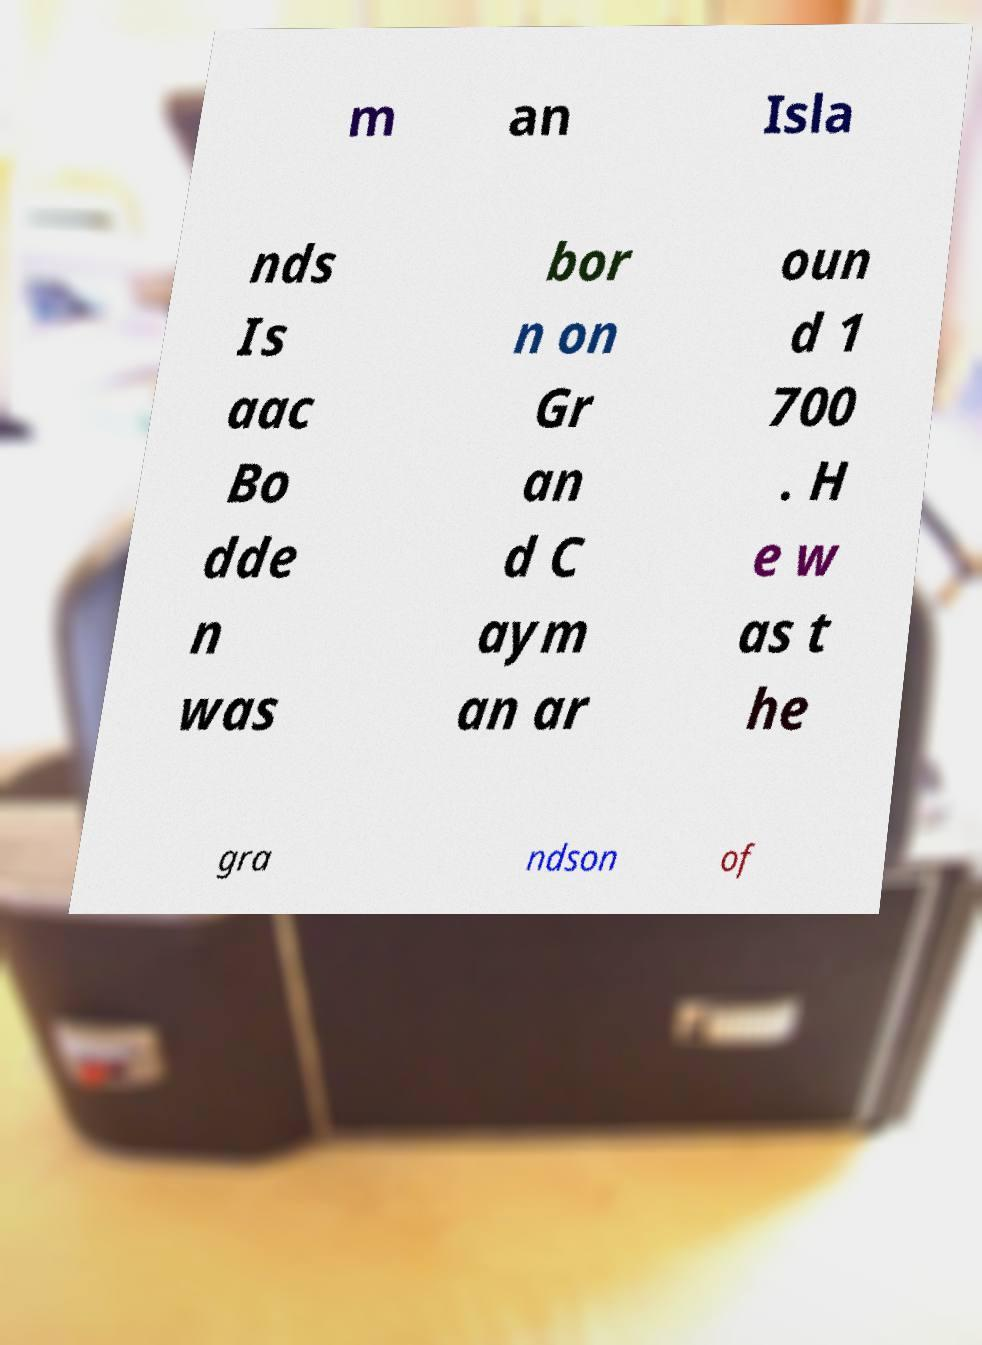Can you accurately transcribe the text from the provided image for me? m an Isla nds Is aac Bo dde n was bor n on Gr an d C aym an ar oun d 1 700 . H e w as t he gra ndson of 